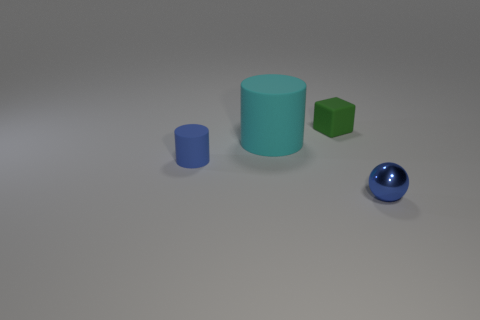Subtract 1 balls. How many balls are left? 0 Add 2 blue cylinders. How many objects exist? 6 Subtract all blue cylinders. How many cylinders are left? 1 Subtract 0 green cylinders. How many objects are left? 4 Subtract all cubes. How many objects are left? 3 Subtract all brown cylinders. Subtract all gray balls. How many cylinders are left? 2 Subtract all purple spheres. How many blue cylinders are left? 1 Subtract all cylinders. Subtract all tiny spheres. How many objects are left? 1 Add 3 large cyan rubber cylinders. How many large cyan rubber cylinders are left? 4 Add 3 brown matte cubes. How many brown matte cubes exist? 3 